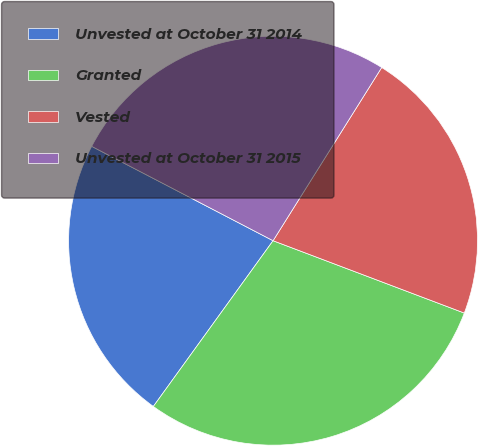Convert chart to OTSL. <chart><loc_0><loc_0><loc_500><loc_500><pie_chart><fcel>Unvested at October 31 2014<fcel>Granted<fcel>Vested<fcel>Unvested at October 31 2015<nl><fcel>22.68%<fcel>29.2%<fcel>21.84%<fcel>26.28%<nl></chart> 